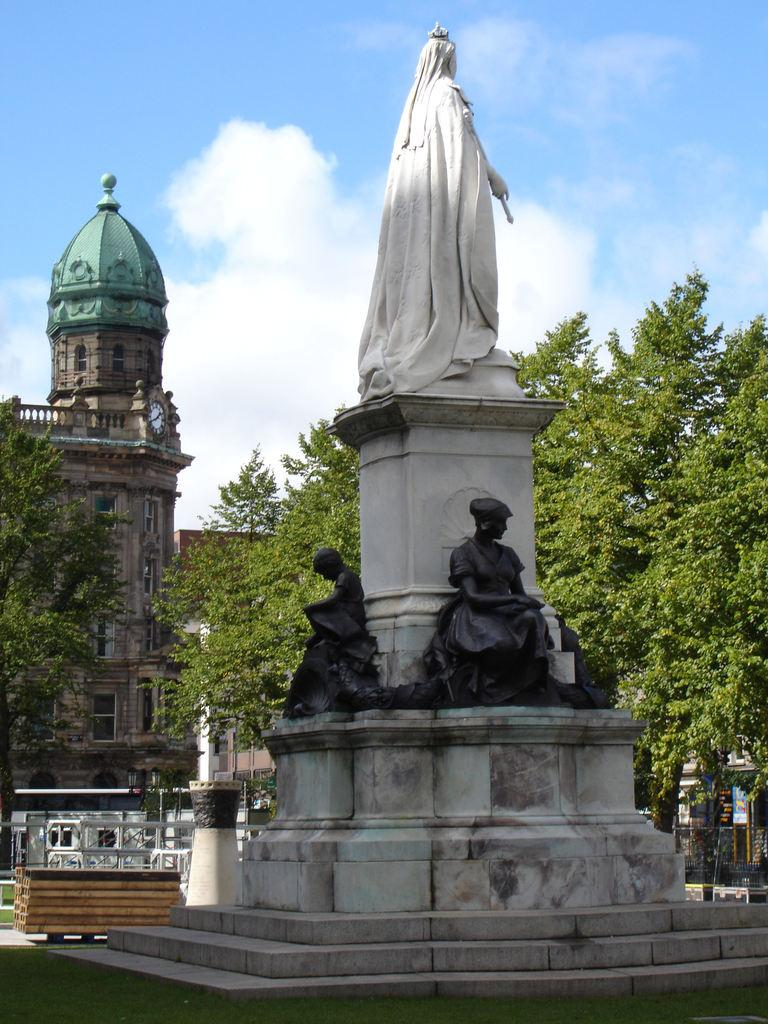What is the main subject of the image? The main subject of the image is many statues. What is the setting of the statues? The statues are surrounded by grass. What other natural elements can be seen in the image? Trees are present in the image. What man-made structures are visible in the image? Buildings are visible in the image. What is the color of the sky in the image? The sky is blue in the image. What verse is being recited by the statues in the image? There are no statues reciting verses in the image; they are stationary and not engaged in any activity. 